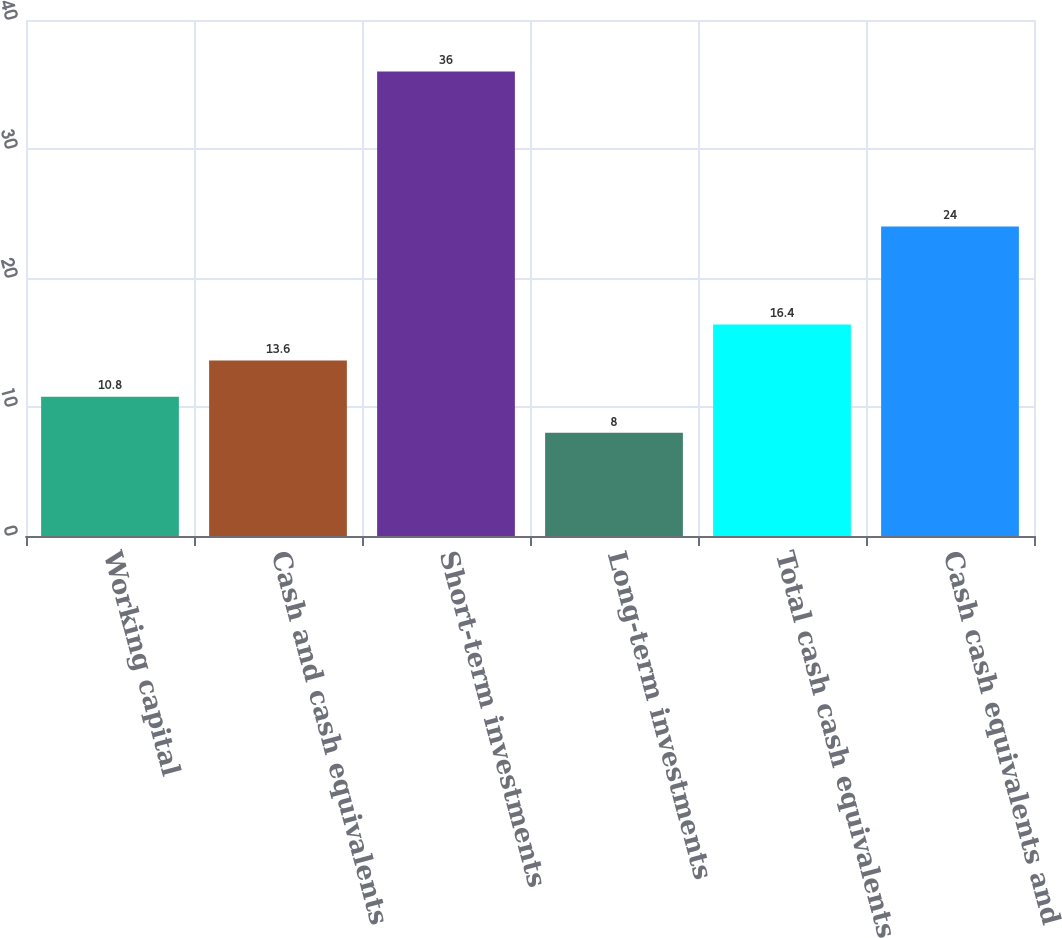Convert chart to OTSL. <chart><loc_0><loc_0><loc_500><loc_500><bar_chart><fcel>Working capital<fcel>Cash and cash equivalents<fcel>Short-term investments<fcel>Long-term investments<fcel>Total cash cash equivalents<fcel>Cash cash equivalents and<nl><fcel>10.8<fcel>13.6<fcel>36<fcel>8<fcel>16.4<fcel>24<nl></chart> 